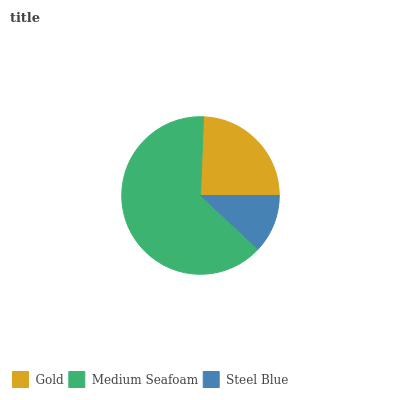Is Steel Blue the minimum?
Answer yes or no. Yes. Is Medium Seafoam the maximum?
Answer yes or no. Yes. Is Medium Seafoam the minimum?
Answer yes or no. No. Is Steel Blue the maximum?
Answer yes or no. No. Is Medium Seafoam greater than Steel Blue?
Answer yes or no. Yes. Is Steel Blue less than Medium Seafoam?
Answer yes or no. Yes. Is Steel Blue greater than Medium Seafoam?
Answer yes or no. No. Is Medium Seafoam less than Steel Blue?
Answer yes or no. No. Is Gold the high median?
Answer yes or no. Yes. Is Gold the low median?
Answer yes or no. Yes. Is Steel Blue the high median?
Answer yes or no. No. Is Steel Blue the low median?
Answer yes or no. No. 